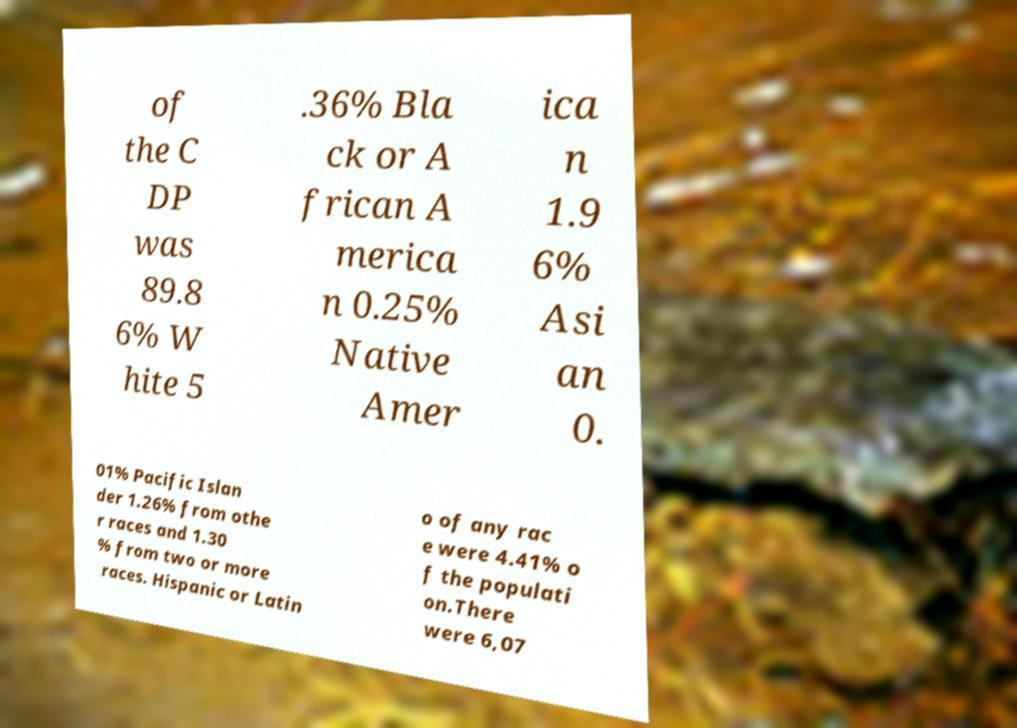What messages or text are displayed in this image? I need them in a readable, typed format. of the C DP was 89.8 6% W hite 5 .36% Bla ck or A frican A merica n 0.25% Native Amer ica n 1.9 6% Asi an 0. 01% Pacific Islan der 1.26% from othe r races and 1.30 % from two or more races. Hispanic or Latin o of any rac e were 4.41% o f the populati on.There were 6,07 